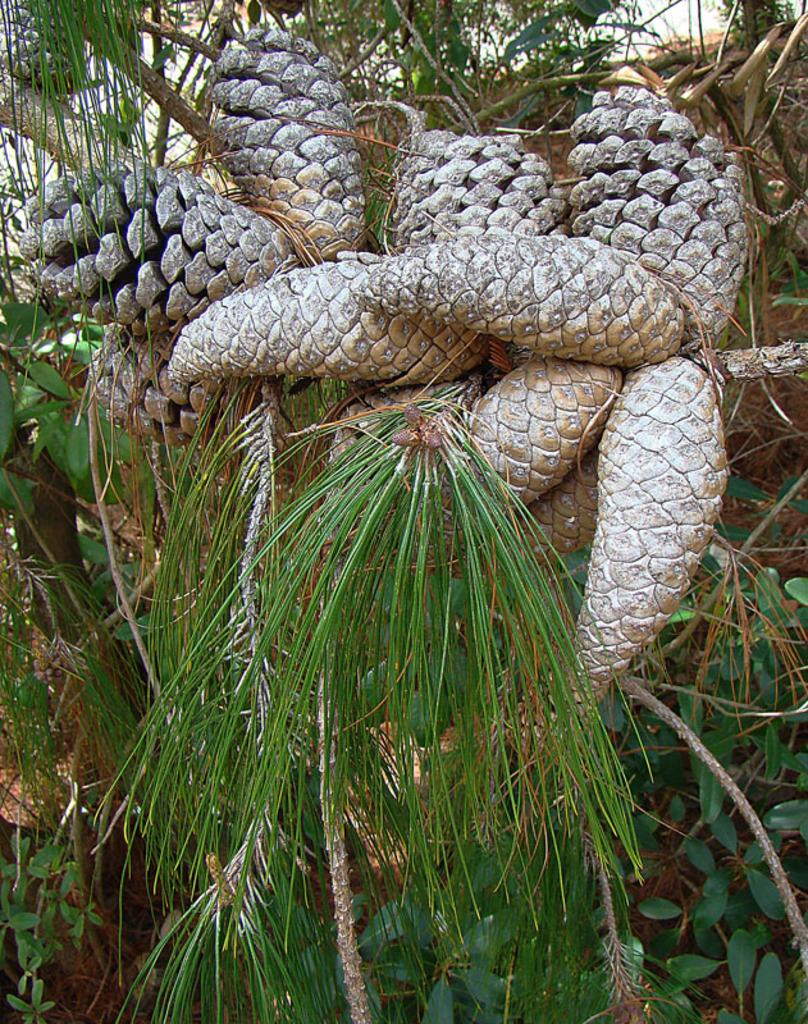What type of vegetation can be seen in the image? There are trees in the image. What objects can be found on the ground near the trees? There are pine cones in the image. Can you see any animals from the zoo in the image? There is no zoo or animals present in the image; it only features trees and pine cones. What is the process of rubbing the pine cones in the image? There is no action of rubbing the pine cones in the image; they are simply lying on the ground. 